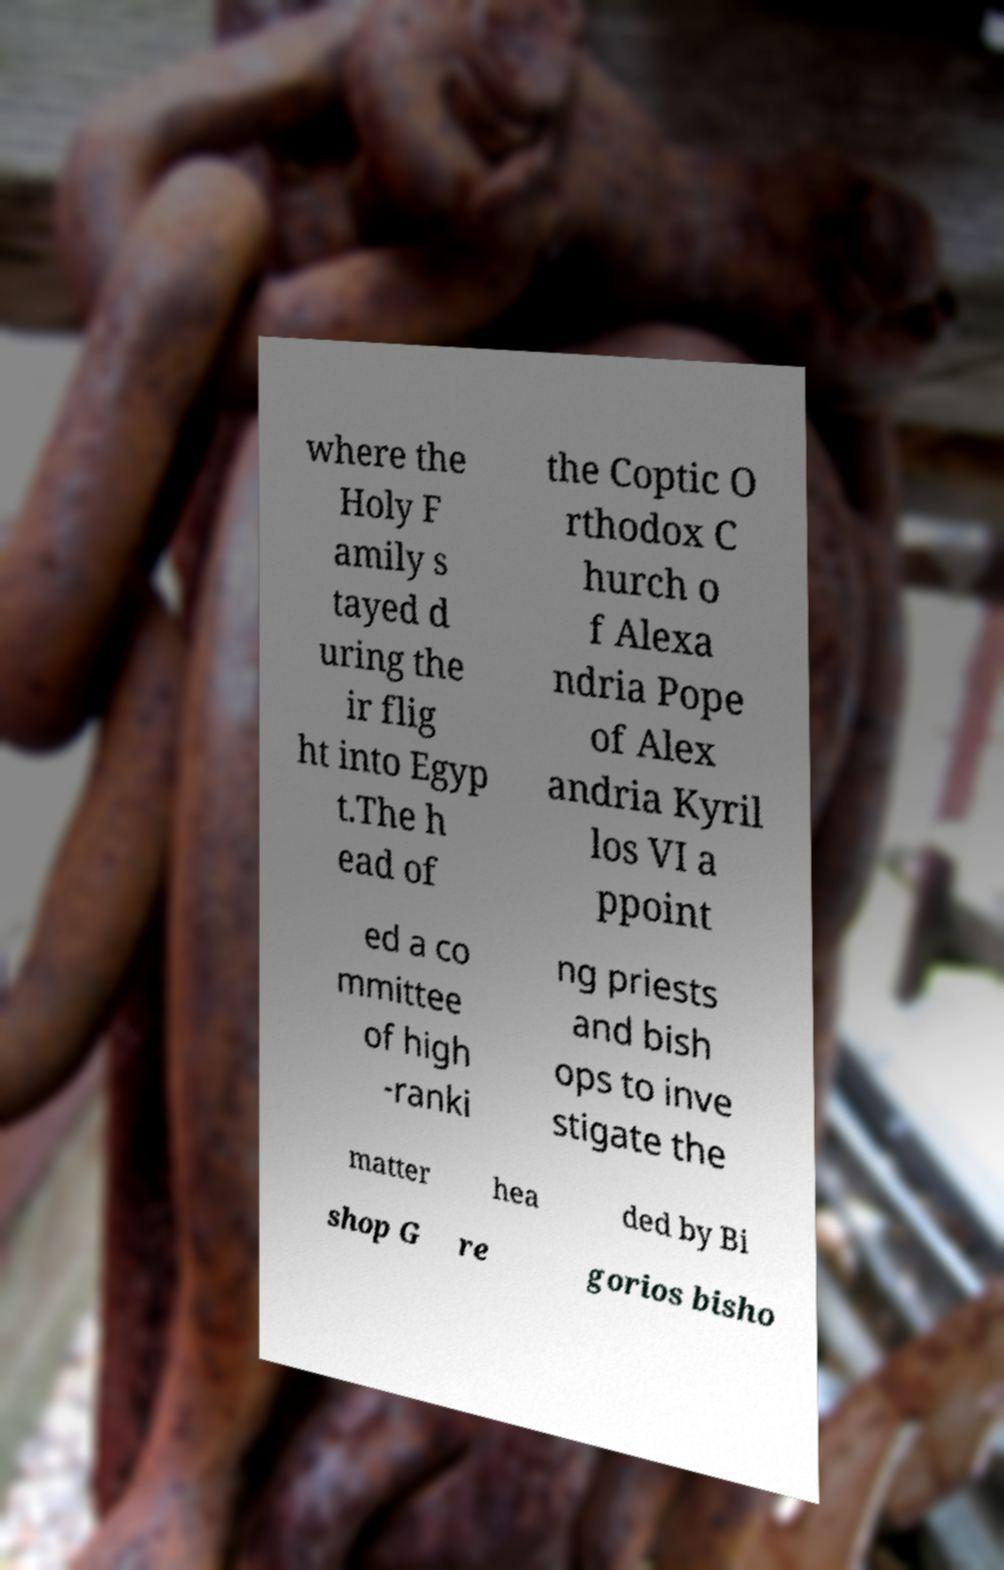What messages or text are displayed in this image? I need them in a readable, typed format. where the Holy F amily s tayed d uring the ir flig ht into Egyp t.The h ead of the Coptic O rthodox C hurch o f Alexa ndria Pope of Alex andria Kyril los VI a ppoint ed a co mmittee of high -ranki ng priests and bish ops to inve stigate the matter hea ded by Bi shop G re gorios bisho 